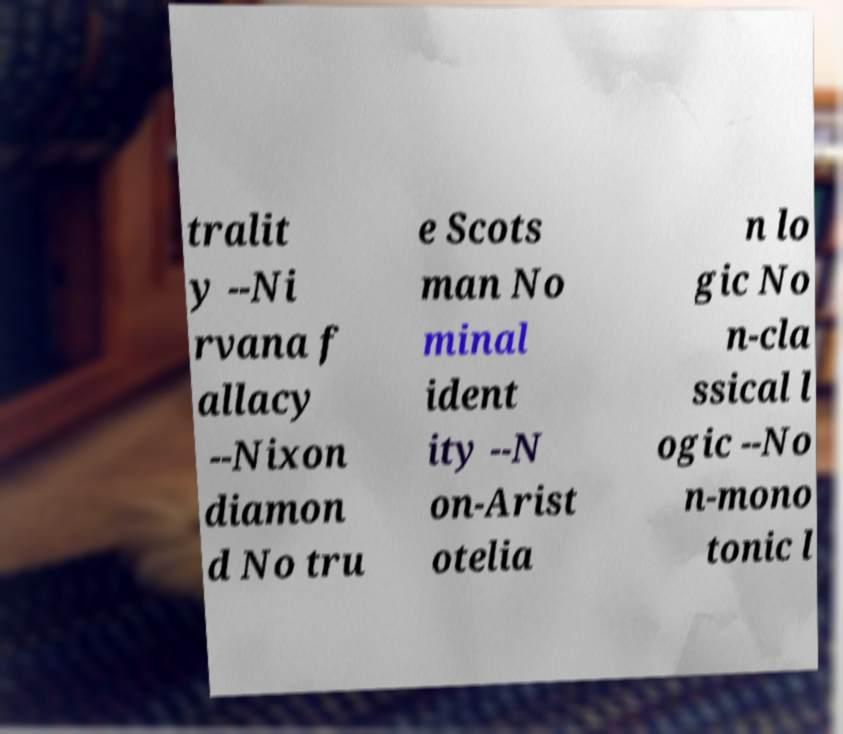Can you read and provide the text displayed in the image?This photo seems to have some interesting text. Can you extract and type it out for me? tralit y --Ni rvana f allacy --Nixon diamon d No tru e Scots man No minal ident ity --N on-Arist otelia n lo gic No n-cla ssical l ogic --No n-mono tonic l 